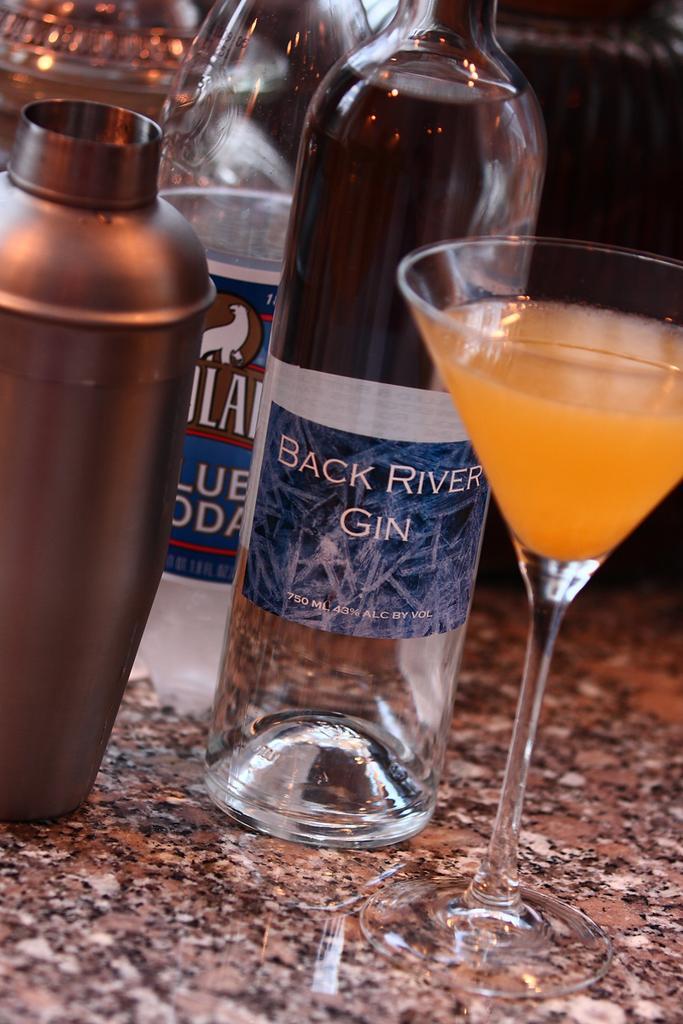Please provide a concise description of this image. This image consists of two bottles a glass and a metal bottle. The two bottles are alcohol Bottles, And there is some drink which is in orange color in the glass. 